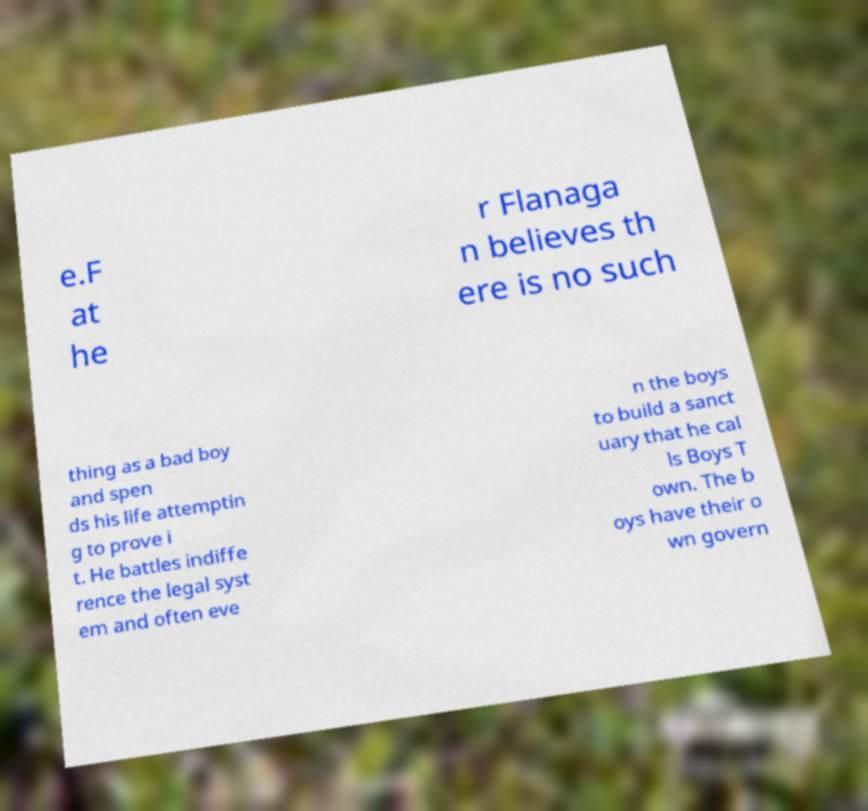Please identify and transcribe the text found in this image. e.F at he r Flanaga n believes th ere is no such thing as a bad boy and spen ds his life attemptin g to prove i t. He battles indiffe rence the legal syst em and often eve n the boys to build a sanct uary that he cal ls Boys T own. The b oys have their o wn govern 